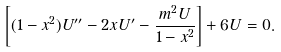<formula> <loc_0><loc_0><loc_500><loc_500>\left [ ( 1 - x ^ { 2 } ) U ^ { \prime \prime } - 2 x U ^ { \prime } - \frac { m ^ { 2 } U } { 1 - x ^ { 2 } } \right ] + 6 U = 0 .</formula> 